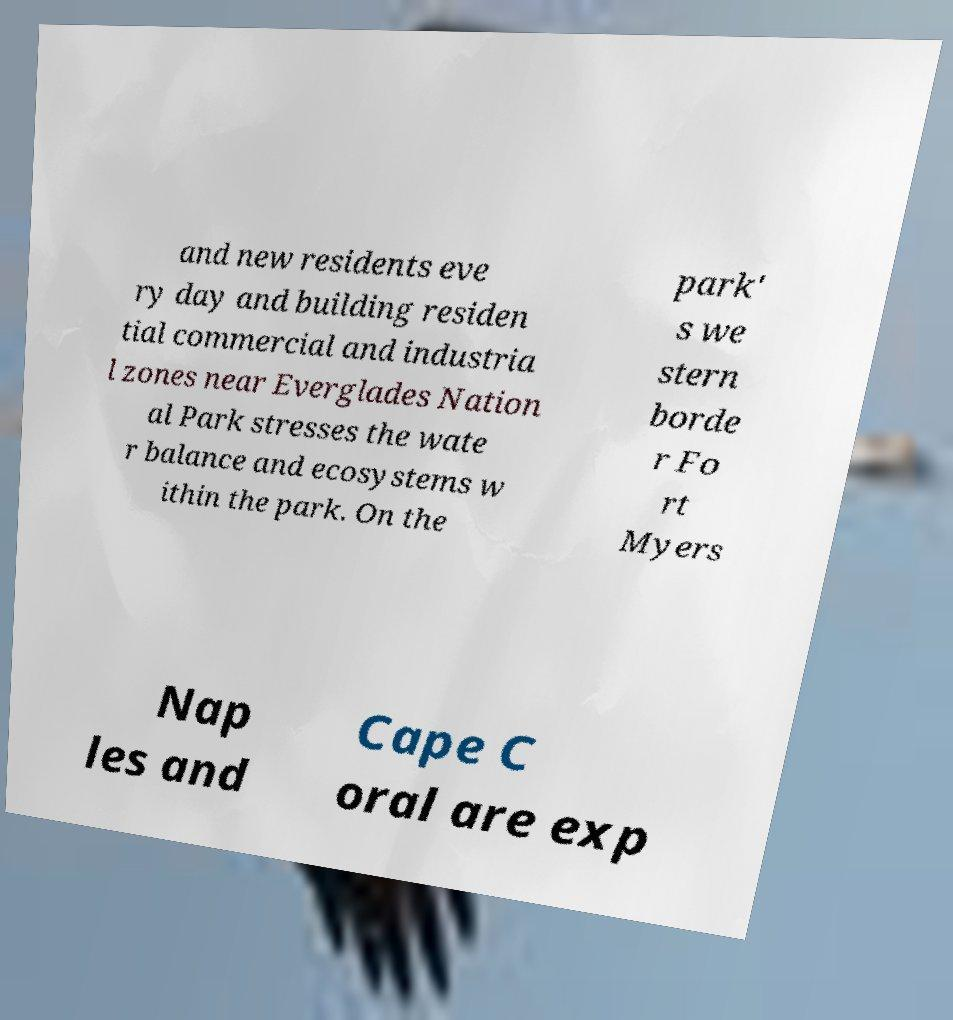What messages or text are displayed in this image? I need them in a readable, typed format. and new residents eve ry day and building residen tial commercial and industria l zones near Everglades Nation al Park stresses the wate r balance and ecosystems w ithin the park. On the park' s we stern borde r Fo rt Myers Nap les and Cape C oral are exp 